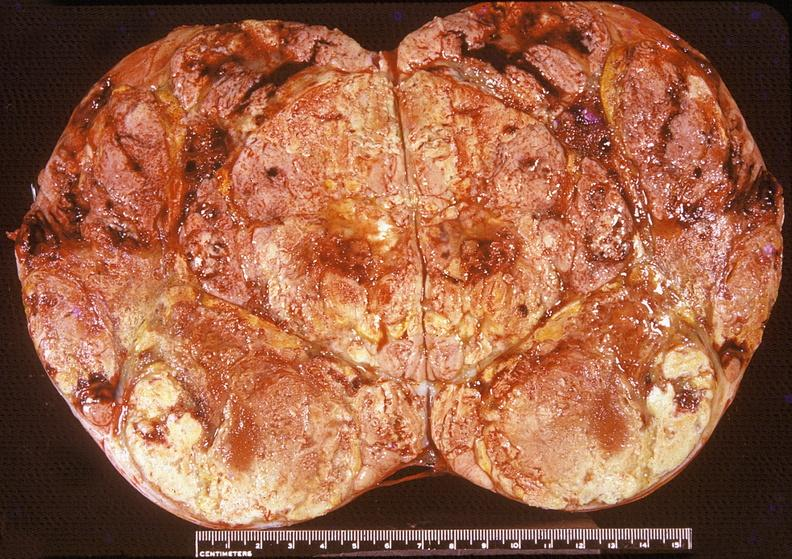what does this image show?
Answer the question using a single word or phrase. Adrenal 